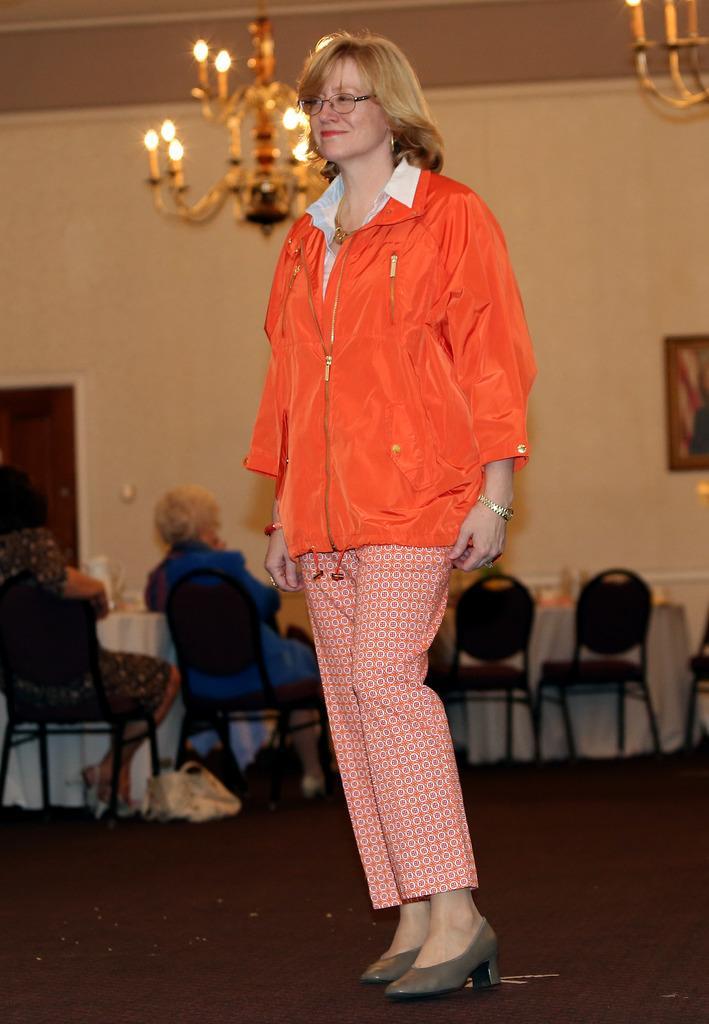Could you give a brief overview of what you see in this image? In this image I can see a person standing. To the back of her there are people sitting and there are lights and the frames attached to the wall. 